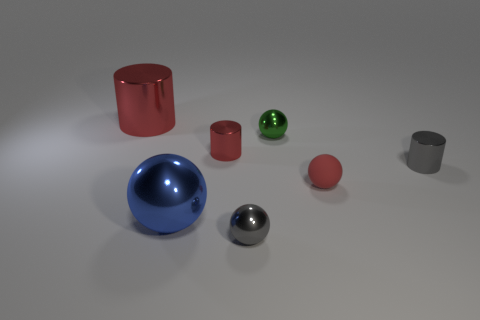Is there anything else that has the same material as the large blue ball?
Your answer should be compact. Yes. How many other things are the same shape as the rubber thing?
Offer a very short reply. 3. What color is the metallic ball that is both in front of the rubber object and on the right side of the large metallic sphere?
Offer a very short reply. Gray. Is there any other thing that is the same size as the red rubber sphere?
Your answer should be very brief. Yes. Is the color of the shiny sphere that is behind the tiny red matte object the same as the matte ball?
Make the answer very short. No. How many cylinders are small blue metallic objects or red metal things?
Ensure brevity in your answer.  2. What is the shape of the large thing that is in front of the large shiny cylinder?
Your answer should be very brief. Sphere. What color is the large shiny object behind the big metallic object that is in front of the red cylinder that is on the right side of the large sphere?
Give a very brief answer. Red. Is the blue sphere made of the same material as the small red sphere?
Offer a very short reply. No. How many yellow things are either tiny metal balls or big objects?
Give a very brief answer. 0. 